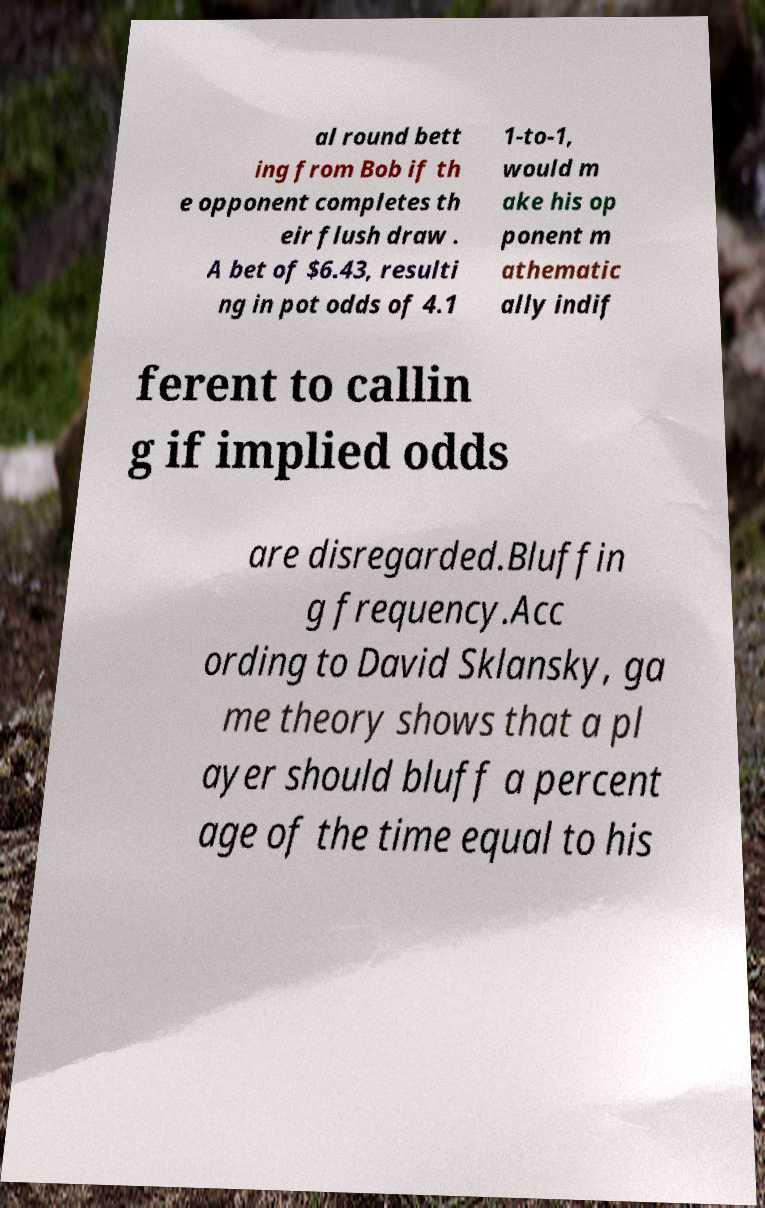For documentation purposes, I need the text within this image transcribed. Could you provide that? al round bett ing from Bob if th e opponent completes th eir flush draw . A bet of $6.43, resulti ng in pot odds of 4.1 1-to-1, would m ake his op ponent m athematic ally indif ferent to callin g if implied odds are disregarded.Bluffin g frequency.Acc ording to David Sklansky, ga me theory shows that a pl ayer should bluff a percent age of the time equal to his 